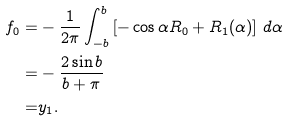<formula> <loc_0><loc_0><loc_500><loc_500>f _ { 0 } = & - \frac { 1 } { 2 \pi } \int _ { - b } ^ { b } \left [ - \cos \alpha R _ { 0 } + R _ { 1 } ( \alpha ) \right ] \, d \alpha \\ = & - \frac { 2 \sin b } { b + \pi } \\ = & y _ { 1 } .</formula> 